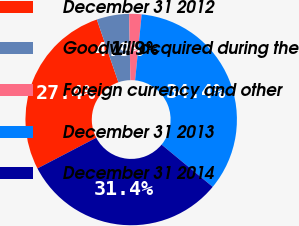<chart> <loc_0><loc_0><loc_500><loc_500><pie_chart><fcel>December 31 2012<fcel>Goodwill acquired during the<fcel>Foreign currency and other<fcel>December 31 2013<fcel>December 31 2014<nl><fcel>27.39%<fcel>4.95%<fcel>1.9%<fcel>34.41%<fcel>31.36%<nl></chart> 